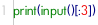<code> <loc_0><loc_0><loc_500><loc_500><_Python_>print(input()[:3])</code> 